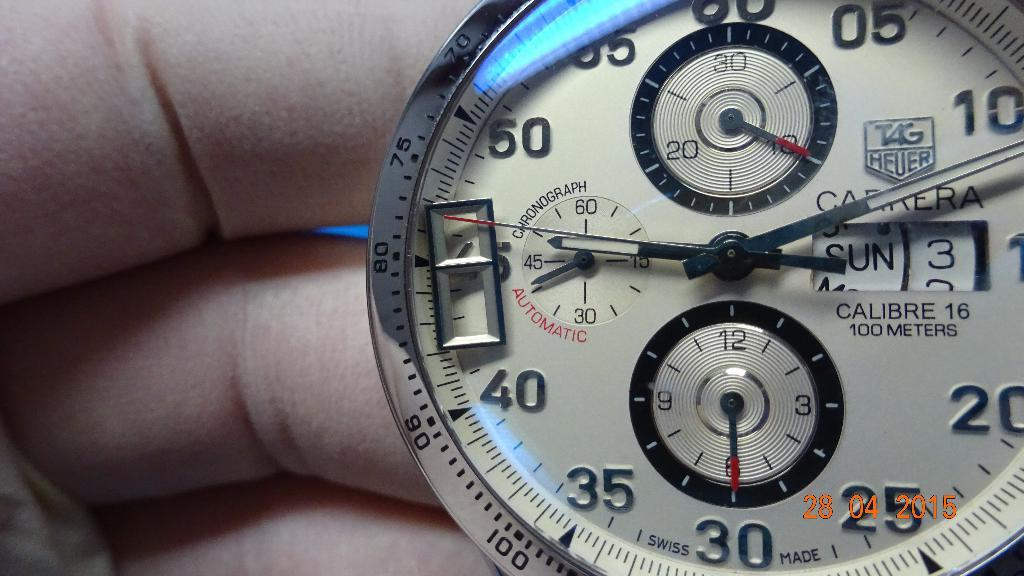<image>
Share a concise interpretation of the image provided. A clock has the words "CALIBRE 16 100 METERS" on the face. 